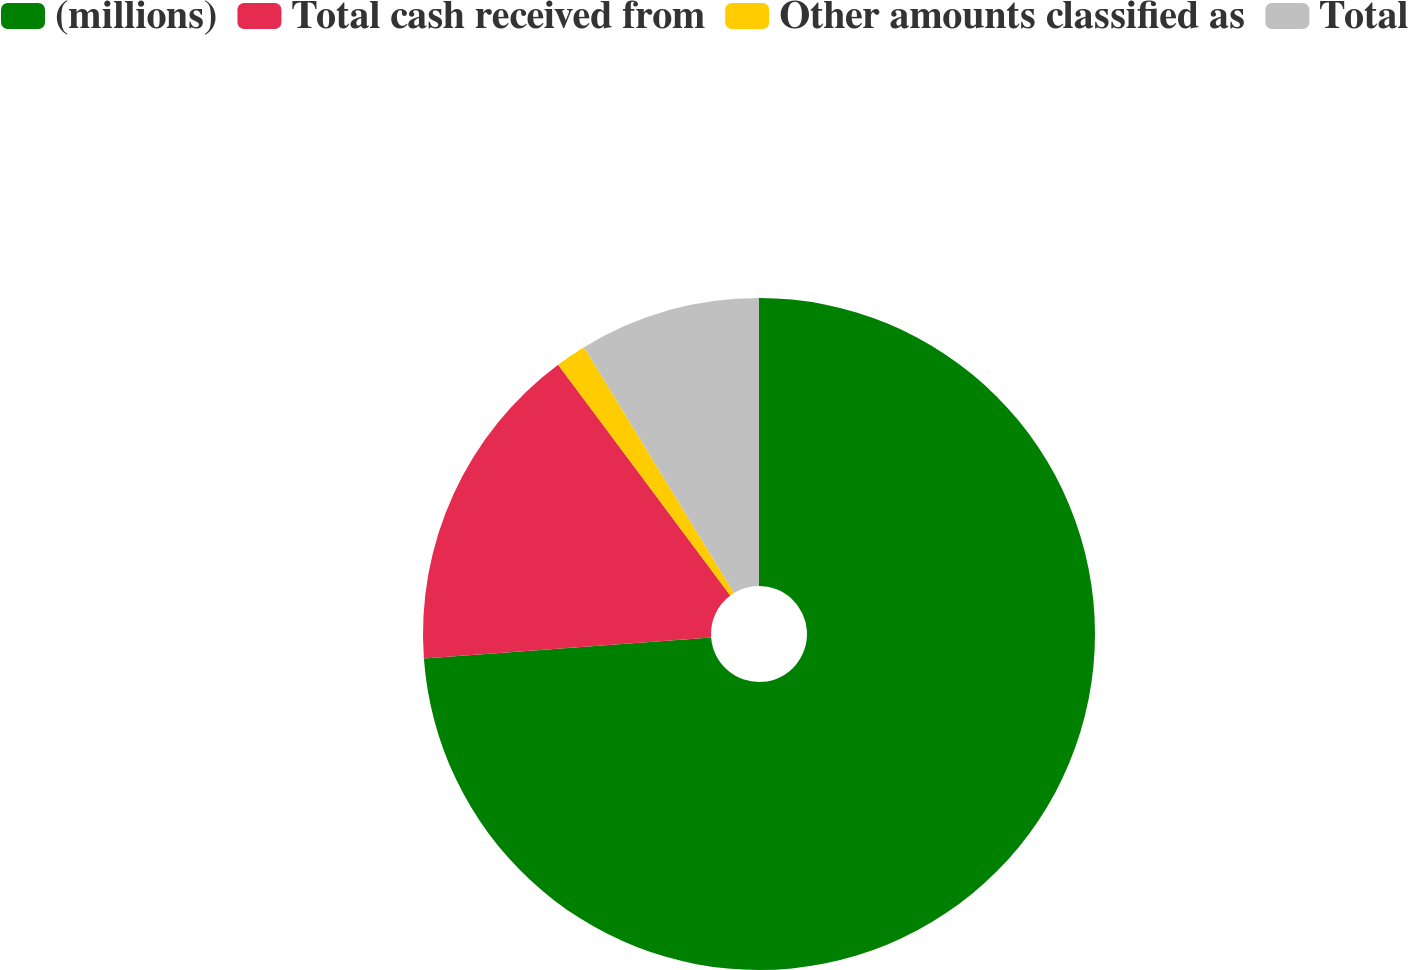Convert chart. <chart><loc_0><loc_0><loc_500><loc_500><pie_chart><fcel>(millions)<fcel>Total cash received from<fcel>Other amounts classified as<fcel>Total<nl><fcel>73.84%<fcel>15.96%<fcel>1.48%<fcel>8.72%<nl></chart> 